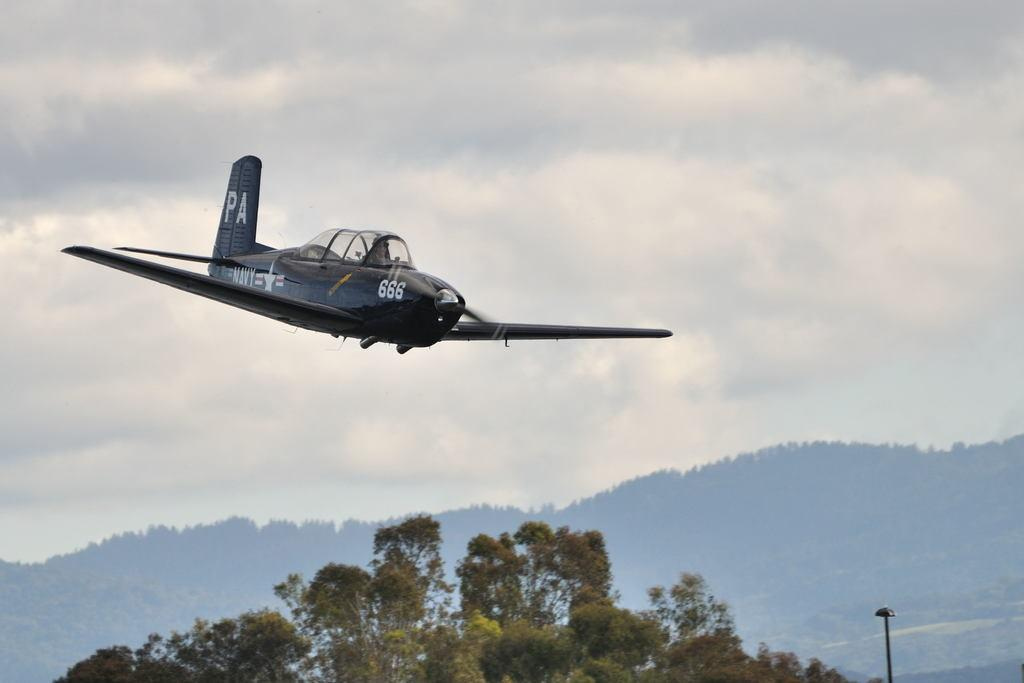Provide a one-sentence caption for the provided image. PA plane 666 flying on a cloudy day. 